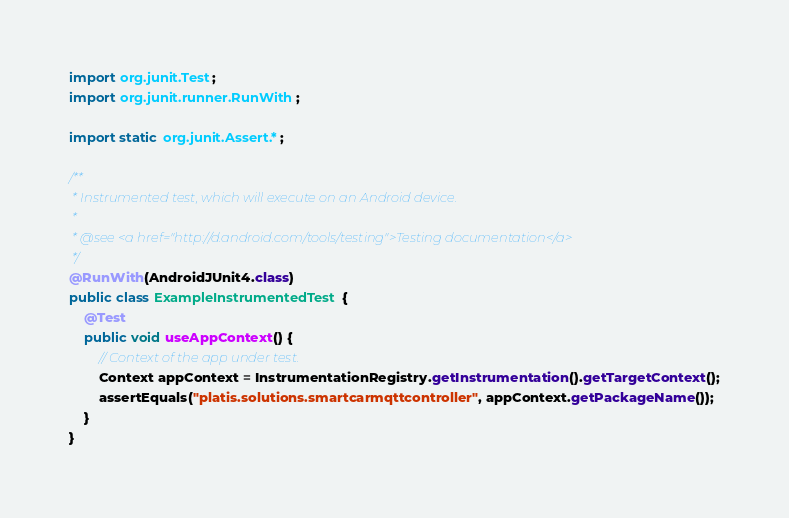<code> <loc_0><loc_0><loc_500><loc_500><_Java_>
import org.junit.Test;
import org.junit.runner.RunWith;

import static org.junit.Assert.*;

/**
 * Instrumented test, which will execute on an Android device.
 *
 * @see <a href="http://d.android.com/tools/testing">Testing documentation</a>
 */
@RunWith(AndroidJUnit4.class)
public class ExampleInstrumentedTest {
    @Test
    public void useAppContext() {
        // Context of the app under test.
        Context appContext = InstrumentationRegistry.getInstrumentation().getTargetContext();
        assertEquals("platis.solutions.smartcarmqttcontroller", appContext.getPackageName());
    }
}</code> 